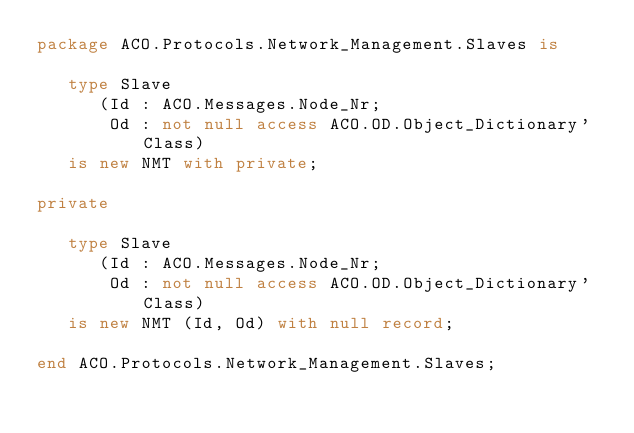Convert code to text. <code><loc_0><loc_0><loc_500><loc_500><_Ada_>package ACO.Protocols.Network_Management.Slaves is

   type Slave
      (Id : ACO.Messages.Node_Nr;
       Od : not null access ACO.OD.Object_Dictionary'Class)
   is new NMT with private;

private

   type Slave
      (Id : ACO.Messages.Node_Nr;
       Od : not null access ACO.OD.Object_Dictionary'Class)
   is new NMT (Id, Od) with null record;

end ACO.Protocols.Network_Management.Slaves;
</code> 